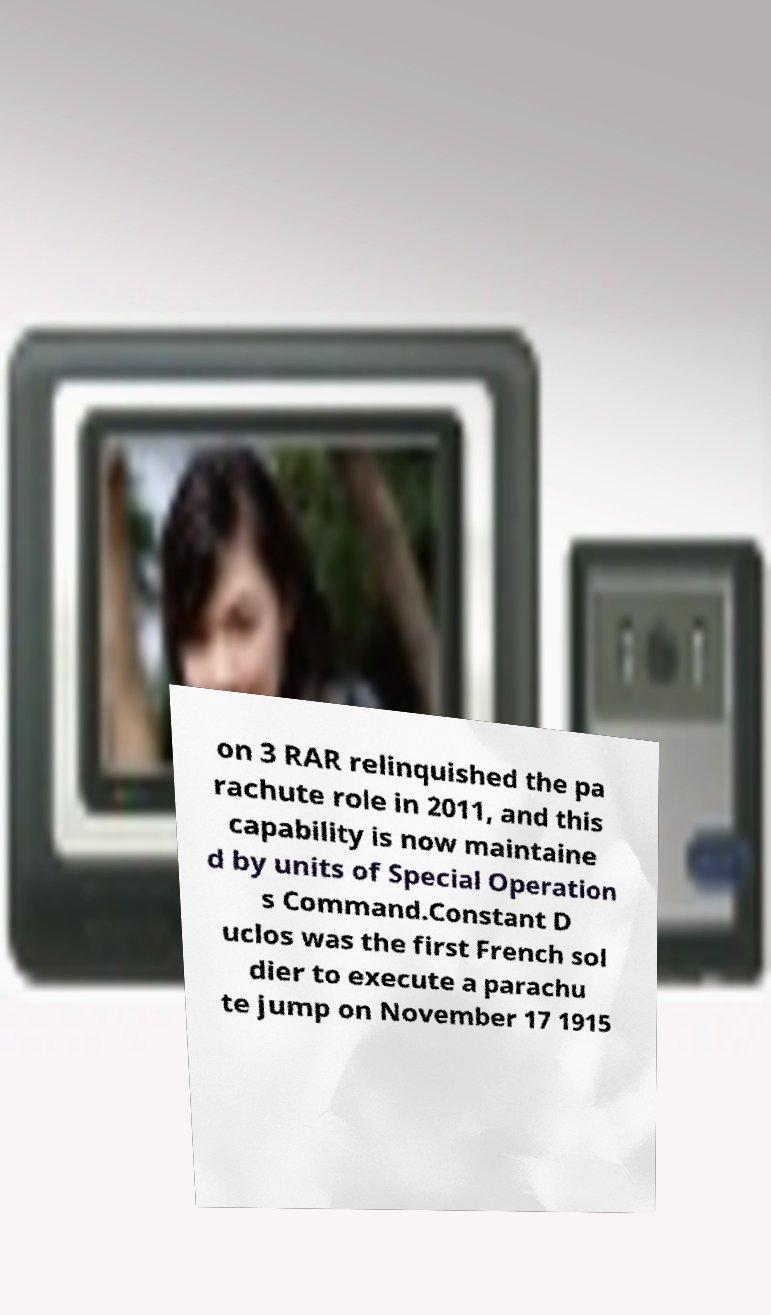Please read and relay the text visible in this image. What does it say? on 3 RAR relinquished the pa rachute role in 2011, and this capability is now maintaine d by units of Special Operation s Command.Constant D uclos was the first French sol dier to execute a parachu te jump on November 17 1915 